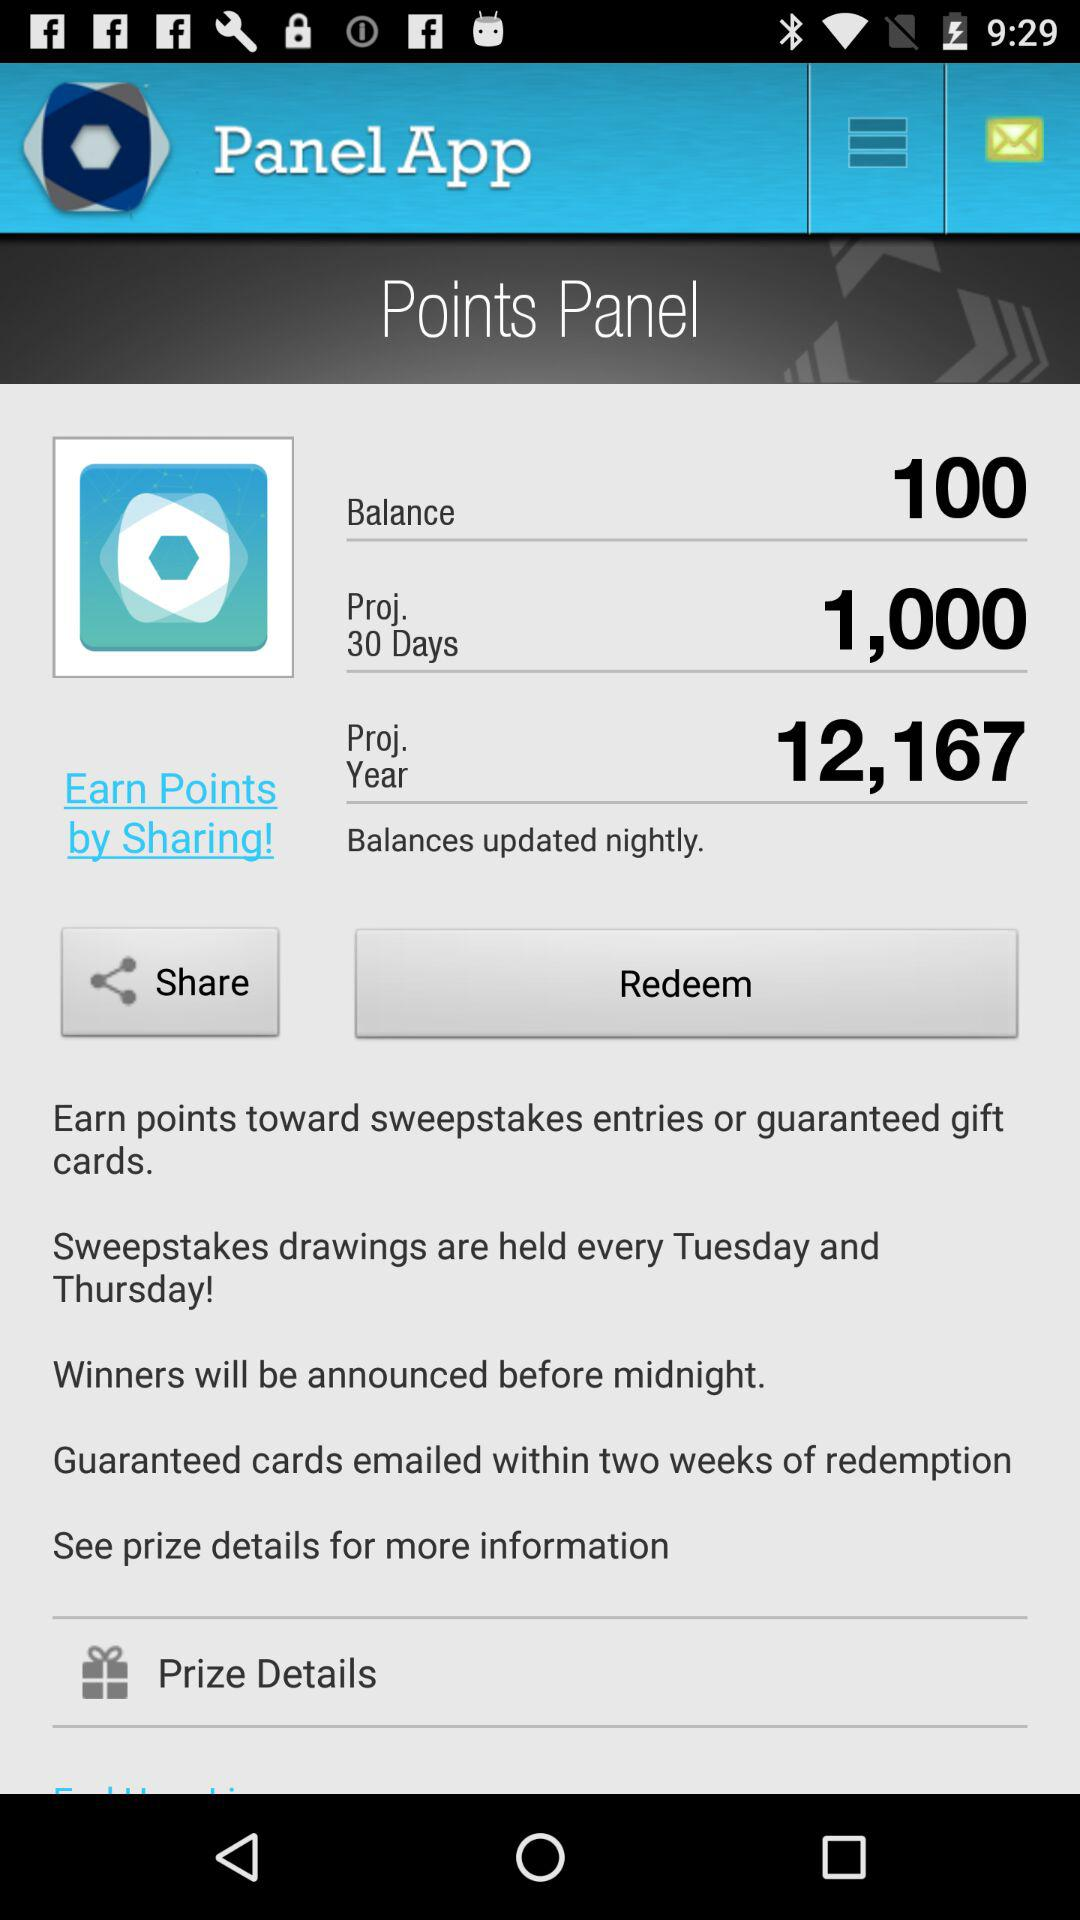How many points are there for projected year? There are 12,167 points. 